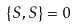<formula> <loc_0><loc_0><loc_500><loc_500>\{ S , S \} = 0</formula> 